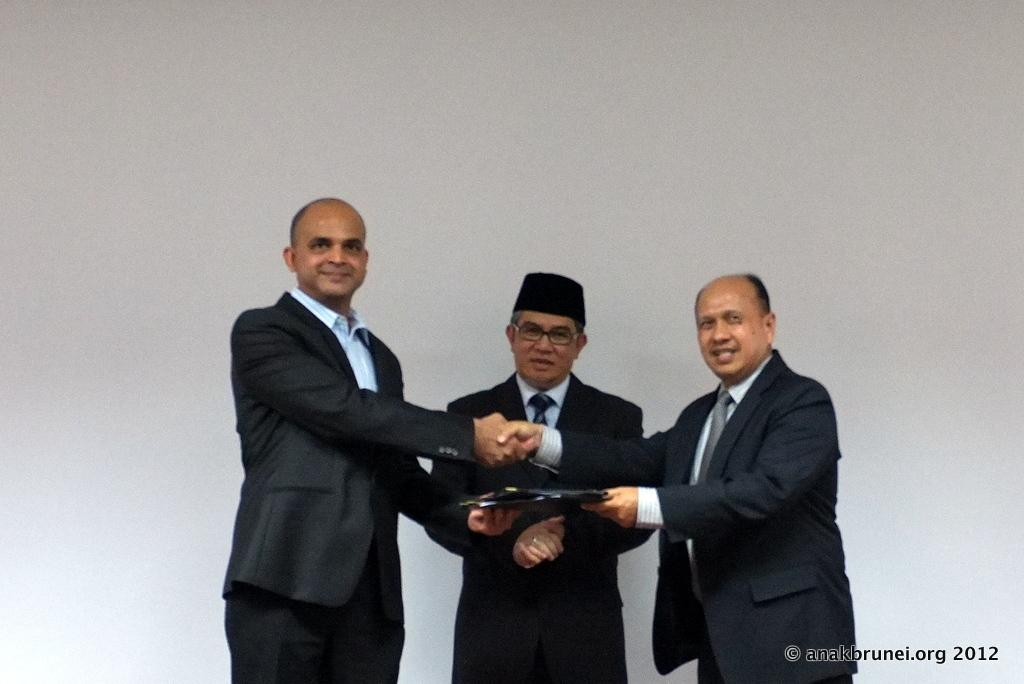How many people are present in the image? There are three people in the image. What are the people doing in the image? The people are shaking hands and exchanging a memorandum. What can be seen at the bottom of the image? There is some text at the bottom of the image. What is visible in the background of the image? There is a wall in the background of the image. What type of mailbox can be seen in the image? There is no mailbox present in the image. What is the mindset of the people in the image? The image does not provide information about the mindset of the people; it only shows them shaking hands and exchanging a memorandum. 